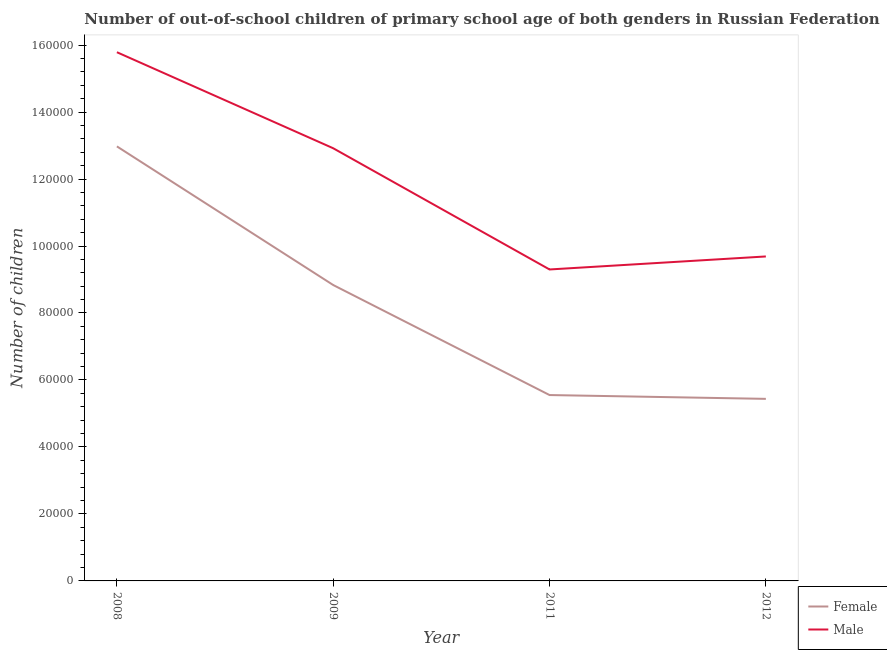How many different coloured lines are there?
Give a very brief answer. 2. What is the number of male out-of-school students in 2009?
Provide a short and direct response. 1.29e+05. Across all years, what is the maximum number of male out-of-school students?
Provide a succinct answer. 1.58e+05. Across all years, what is the minimum number of male out-of-school students?
Provide a succinct answer. 9.30e+04. In which year was the number of male out-of-school students maximum?
Offer a very short reply. 2008. In which year was the number of female out-of-school students minimum?
Your answer should be very brief. 2012. What is the total number of male out-of-school students in the graph?
Make the answer very short. 4.77e+05. What is the difference between the number of female out-of-school students in 2008 and that in 2009?
Your response must be concise. 4.14e+04. What is the difference between the number of female out-of-school students in 2009 and the number of male out-of-school students in 2008?
Keep it short and to the point. -6.95e+04. What is the average number of female out-of-school students per year?
Offer a terse response. 8.20e+04. In the year 2009, what is the difference between the number of female out-of-school students and number of male out-of-school students?
Your answer should be very brief. -4.08e+04. In how many years, is the number of male out-of-school students greater than 24000?
Provide a short and direct response. 4. What is the ratio of the number of male out-of-school students in 2008 to that in 2011?
Give a very brief answer. 1.7. What is the difference between the highest and the second highest number of male out-of-school students?
Your answer should be compact. 2.87e+04. What is the difference between the highest and the lowest number of male out-of-school students?
Provide a short and direct response. 6.49e+04. In how many years, is the number of female out-of-school students greater than the average number of female out-of-school students taken over all years?
Offer a terse response. 2. Where does the legend appear in the graph?
Your response must be concise. Bottom right. How many legend labels are there?
Ensure brevity in your answer.  2. What is the title of the graph?
Provide a short and direct response. Number of out-of-school children of primary school age of both genders in Russian Federation. Does "Arms exports" appear as one of the legend labels in the graph?
Offer a terse response. No. What is the label or title of the Y-axis?
Keep it short and to the point. Number of children. What is the Number of children in Female in 2008?
Give a very brief answer. 1.30e+05. What is the Number of children of Male in 2008?
Your answer should be very brief. 1.58e+05. What is the Number of children of Female in 2009?
Ensure brevity in your answer.  8.84e+04. What is the Number of children in Male in 2009?
Your response must be concise. 1.29e+05. What is the Number of children in Female in 2011?
Ensure brevity in your answer.  5.55e+04. What is the Number of children of Male in 2011?
Your answer should be very brief. 9.30e+04. What is the Number of children in Female in 2012?
Your answer should be compact. 5.44e+04. What is the Number of children in Male in 2012?
Keep it short and to the point. 9.69e+04. Across all years, what is the maximum Number of children in Female?
Give a very brief answer. 1.30e+05. Across all years, what is the maximum Number of children of Male?
Provide a short and direct response. 1.58e+05. Across all years, what is the minimum Number of children of Female?
Your answer should be compact. 5.44e+04. Across all years, what is the minimum Number of children in Male?
Offer a very short reply. 9.30e+04. What is the total Number of children of Female in the graph?
Offer a terse response. 3.28e+05. What is the total Number of children of Male in the graph?
Your answer should be very brief. 4.77e+05. What is the difference between the Number of children of Female in 2008 and that in 2009?
Keep it short and to the point. 4.14e+04. What is the difference between the Number of children of Male in 2008 and that in 2009?
Keep it short and to the point. 2.87e+04. What is the difference between the Number of children in Female in 2008 and that in 2011?
Offer a very short reply. 7.42e+04. What is the difference between the Number of children in Male in 2008 and that in 2011?
Ensure brevity in your answer.  6.49e+04. What is the difference between the Number of children in Female in 2008 and that in 2012?
Provide a succinct answer. 7.54e+04. What is the difference between the Number of children in Male in 2008 and that in 2012?
Your answer should be compact. 6.10e+04. What is the difference between the Number of children in Female in 2009 and that in 2011?
Your answer should be compact. 3.29e+04. What is the difference between the Number of children in Male in 2009 and that in 2011?
Offer a very short reply. 3.62e+04. What is the difference between the Number of children of Female in 2009 and that in 2012?
Make the answer very short. 3.40e+04. What is the difference between the Number of children in Male in 2009 and that in 2012?
Keep it short and to the point. 3.23e+04. What is the difference between the Number of children of Female in 2011 and that in 2012?
Your answer should be compact. 1138. What is the difference between the Number of children in Male in 2011 and that in 2012?
Your answer should be compact. -3887. What is the difference between the Number of children of Female in 2008 and the Number of children of Male in 2009?
Provide a short and direct response. 559. What is the difference between the Number of children in Female in 2008 and the Number of children in Male in 2011?
Keep it short and to the point. 3.68e+04. What is the difference between the Number of children in Female in 2008 and the Number of children in Male in 2012?
Give a very brief answer. 3.29e+04. What is the difference between the Number of children of Female in 2009 and the Number of children of Male in 2011?
Your response must be concise. -4646. What is the difference between the Number of children in Female in 2009 and the Number of children in Male in 2012?
Provide a short and direct response. -8533. What is the difference between the Number of children of Female in 2011 and the Number of children of Male in 2012?
Keep it short and to the point. -4.14e+04. What is the average Number of children of Female per year?
Ensure brevity in your answer.  8.20e+04. What is the average Number of children of Male per year?
Make the answer very short. 1.19e+05. In the year 2008, what is the difference between the Number of children of Female and Number of children of Male?
Your answer should be very brief. -2.81e+04. In the year 2009, what is the difference between the Number of children in Female and Number of children in Male?
Offer a very short reply. -4.08e+04. In the year 2011, what is the difference between the Number of children of Female and Number of children of Male?
Provide a succinct answer. -3.75e+04. In the year 2012, what is the difference between the Number of children in Female and Number of children in Male?
Offer a very short reply. -4.25e+04. What is the ratio of the Number of children of Female in 2008 to that in 2009?
Your response must be concise. 1.47. What is the ratio of the Number of children in Male in 2008 to that in 2009?
Offer a terse response. 1.22. What is the ratio of the Number of children in Female in 2008 to that in 2011?
Ensure brevity in your answer.  2.34. What is the ratio of the Number of children of Male in 2008 to that in 2011?
Ensure brevity in your answer.  1.7. What is the ratio of the Number of children in Female in 2008 to that in 2012?
Your response must be concise. 2.39. What is the ratio of the Number of children in Male in 2008 to that in 2012?
Your response must be concise. 1.63. What is the ratio of the Number of children of Female in 2009 to that in 2011?
Your answer should be compact. 1.59. What is the ratio of the Number of children in Male in 2009 to that in 2011?
Provide a succinct answer. 1.39. What is the ratio of the Number of children in Female in 2009 to that in 2012?
Give a very brief answer. 1.63. What is the ratio of the Number of children of Male in 2009 to that in 2012?
Give a very brief answer. 1.33. What is the ratio of the Number of children of Female in 2011 to that in 2012?
Ensure brevity in your answer.  1.02. What is the ratio of the Number of children of Male in 2011 to that in 2012?
Your response must be concise. 0.96. What is the difference between the highest and the second highest Number of children of Female?
Your answer should be very brief. 4.14e+04. What is the difference between the highest and the second highest Number of children in Male?
Your response must be concise. 2.87e+04. What is the difference between the highest and the lowest Number of children in Female?
Ensure brevity in your answer.  7.54e+04. What is the difference between the highest and the lowest Number of children of Male?
Your answer should be very brief. 6.49e+04. 